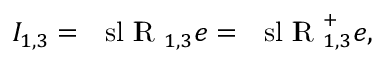Convert formula to latex. <formula><loc_0><loc_0><loc_500><loc_500>I _ { 1 , 3 } = { \ s l I \, R } _ { 1 , 3 } e = { \ s l I \, R } _ { 1 , 3 } ^ { + } e ,</formula> 